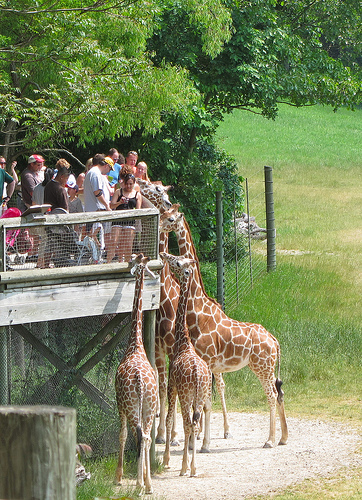How many baby giraffes are there? In the image, there are two baby giraffes present. You can distinguish the young giraffes by their smaller size relative to the adults. Both are close to the fence where visitors of the zoo presumably watch and interact with them. 